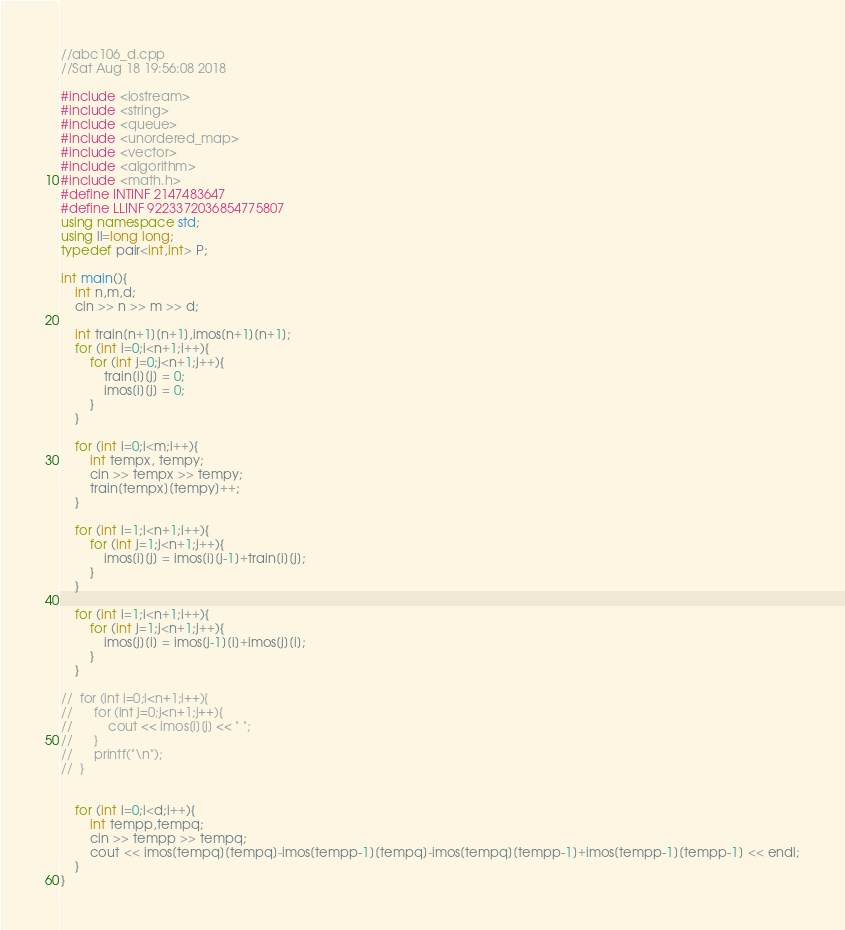Convert code to text. <code><loc_0><loc_0><loc_500><loc_500><_C++_>//abc106_d.cpp
//Sat Aug 18 19:56:08 2018

#include <iostream>
#include <string>
#include <queue>
#include <unordered_map>
#include <vector>
#include <algorithm>
#include <math.h>
#define INTINF 2147483647
#define LLINF 9223372036854775807
using namespace std;
using ll=long long;
typedef pair<int,int> P;

int main(){
	int n,m,d;
	cin >> n >> m >> d;

	int train[n+1][n+1],imos[n+1][n+1];
	for (int i=0;i<n+1;i++){
		for (int j=0;j<n+1;j++){
			train[i][j] = 0;
			imos[i][j] = 0;
		}
	}

	for (int i=0;i<m;i++){
		int tempx, tempy;
		cin >> tempx >> tempy;
		train[tempx][tempy]++;
	}

	for (int i=1;i<n+1;i++){
		for (int j=1;j<n+1;j++){
			imos[i][j] = imos[i][j-1]+train[i][j];
		}
	}

	for (int i=1;i<n+1;i++){
		for (int j=1;j<n+1;j++){
			imos[j][i] = imos[j-1][i]+imos[j][i];
		}
	}

//	for (int i=0;i<n+1;i++){
//		for (int j=0;j<n+1;j++){
//			cout << imos[i][j] << " ";
//		}
//		printf("\n");
//	}


	for (int i=0;i<d;i++){
		int tempp,tempq;
		cin >> tempp >> tempq;
		cout << imos[tempq][tempq]-imos[tempp-1][tempq]-imos[tempq][tempp-1]+imos[tempp-1][tempp-1] << endl;
	}
}</code> 